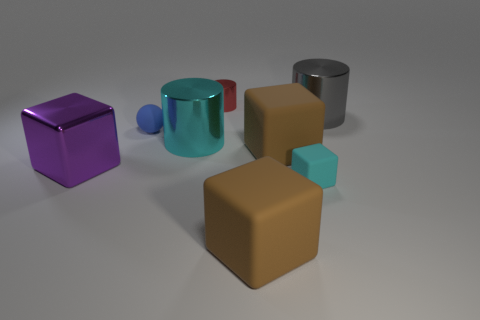There is a big rubber object that is to the left of the brown matte cube behind the small cyan matte cube; what number of shiny objects are left of it?
Ensure brevity in your answer.  3. There is a cylinder that is right of the small cylinder; what color is it?
Ensure brevity in your answer.  Gray. There is a large matte object that is in front of the big shiny block; is its color the same as the tiny cube?
Offer a very short reply. No. There is a red metallic thing that is the same shape as the gray thing; what size is it?
Your answer should be very brief. Small. Is there any other thing that is the same size as the red cylinder?
Your answer should be very brief. Yes. The brown object that is in front of the big brown rubber cube that is behind the large object on the left side of the big cyan object is made of what material?
Your answer should be compact. Rubber. Are there more big purple metallic things on the right side of the big cyan cylinder than brown things that are behind the sphere?
Your answer should be very brief. No. Do the gray cylinder and the cyan block have the same size?
Your answer should be compact. No. There is another tiny thing that is the same shape as the gray shiny thing; what color is it?
Your answer should be very brief. Red. What number of small metal things are the same color as the big shiny cube?
Your answer should be compact. 0. 